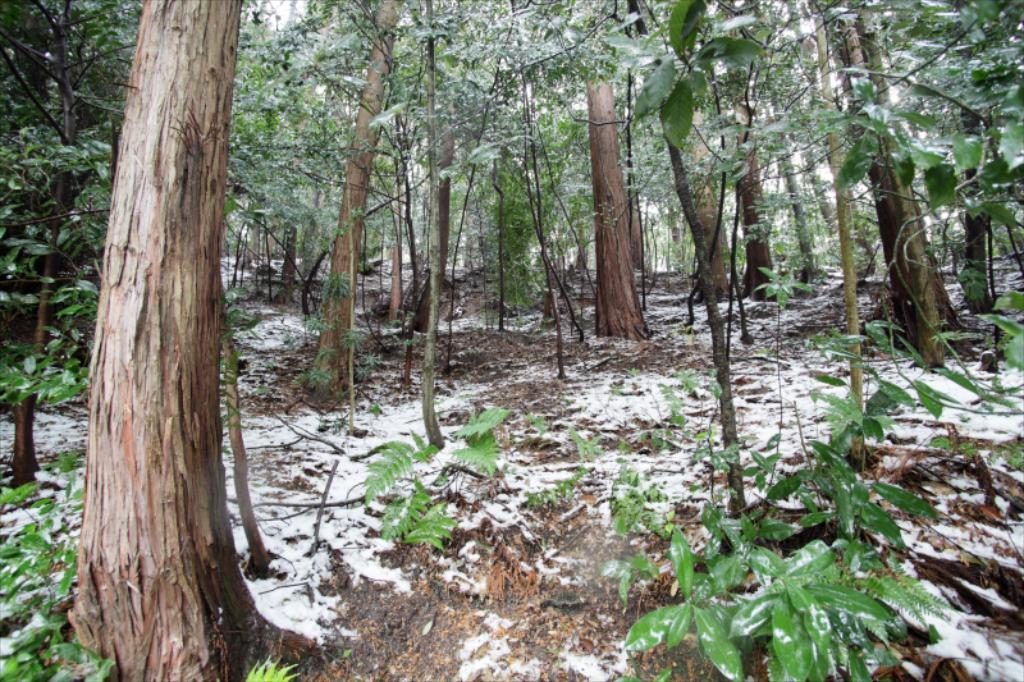What type of vegetation is present in the image? There are trees and plants in the image. Where is the snow located in the image? The snow is at the bottom of the image. How many snakes are slithering through the pie in the image? There are no snakes or pie present in the image. What type of society is depicted in the image? The image does not depict any society; it features trees, plants, and snow. 